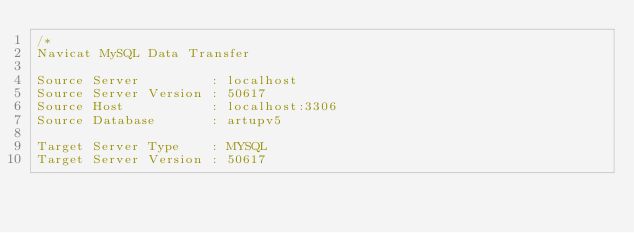<code> <loc_0><loc_0><loc_500><loc_500><_SQL_>/*
Navicat MySQL Data Transfer

Source Server         : localhost
Source Server Version : 50617
Source Host           : localhost:3306
Source Database       : artupv5

Target Server Type    : MYSQL
Target Server Version : 50617</code> 